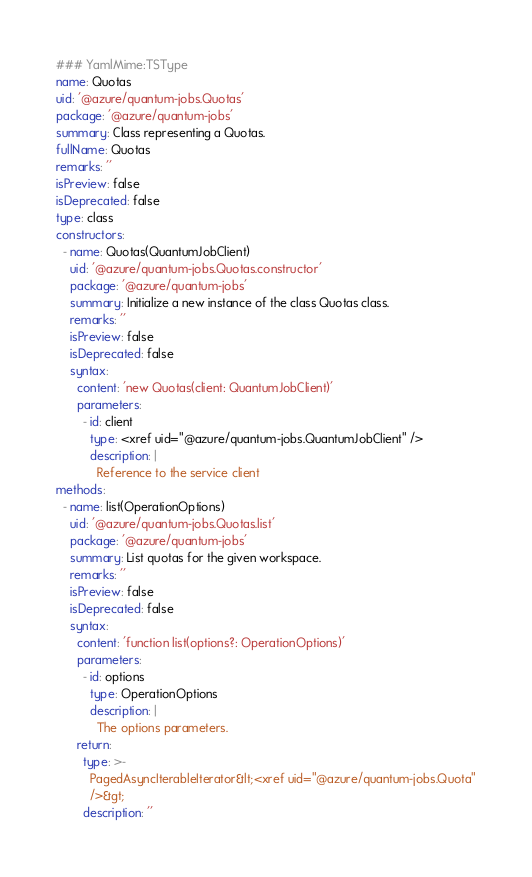Convert code to text. <code><loc_0><loc_0><loc_500><loc_500><_YAML_>### YamlMime:TSType
name: Quotas
uid: '@azure/quantum-jobs.Quotas'
package: '@azure/quantum-jobs'
summary: Class representing a Quotas.
fullName: Quotas
remarks: ''
isPreview: false
isDeprecated: false
type: class
constructors:
  - name: Quotas(QuantumJobClient)
    uid: '@azure/quantum-jobs.Quotas.constructor'
    package: '@azure/quantum-jobs'
    summary: Initialize a new instance of the class Quotas class.
    remarks: ''
    isPreview: false
    isDeprecated: false
    syntax:
      content: 'new Quotas(client: QuantumJobClient)'
      parameters:
        - id: client
          type: <xref uid="@azure/quantum-jobs.QuantumJobClient" />
          description: |
            Reference to the service client
methods:
  - name: list(OperationOptions)
    uid: '@azure/quantum-jobs.Quotas.list'
    package: '@azure/quantum-jobs'
    summary: List quotas for the given workspace.
    remarks: ''
    isPreview: false
    isDeprecated: false
    syntax:
      content: 'function list(options?: OperationOptions)'
      parameters:
        - id: options
          type: OperationOptions
          description: |
            The options parameters.
      return:
        type: >-
          PagedAsyncIterableIterator&lt;<xref uid="@azure/quantum-jobs.Quota"
          />&gt;
        description: ''
</code> 